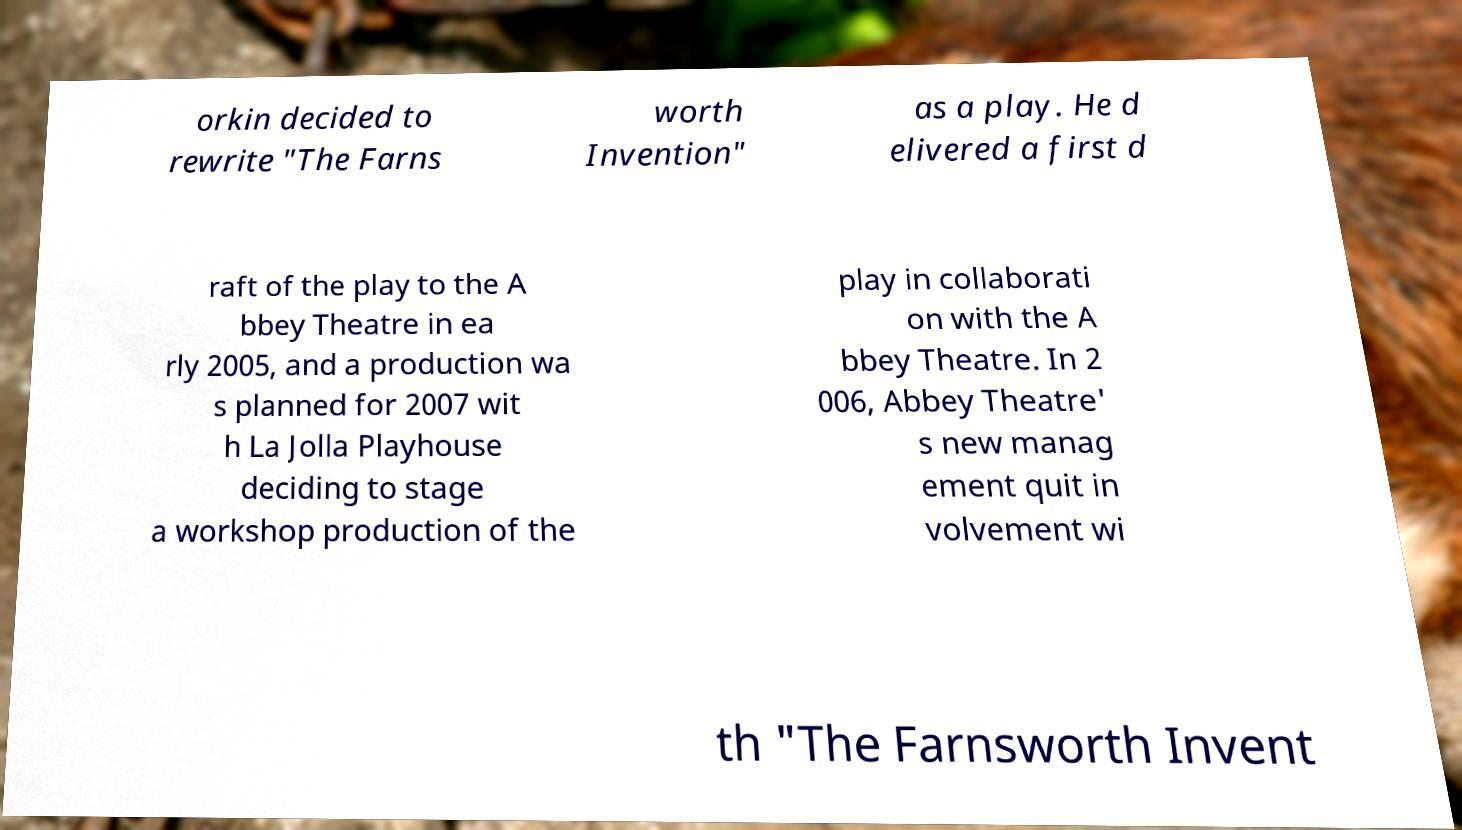Please read and relay the text visible in this image. What does it say? orkin decided to rewrite "The Farns worth Invention" as a play. He d elivered a first d raft of the play to the A bbey Theatre in ea rly 2005, and a production wa s planned for 2007 wit h La Jolla Playhouse deciding to stage a workshop production of the play in collaborati on with the A bbey Theatre. In 2 006, Abbey Theatre' s new manag ement quit in volvement wi th "The Farnsworth Invent 